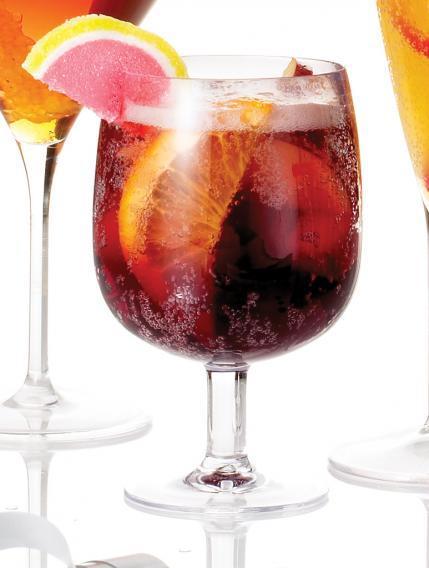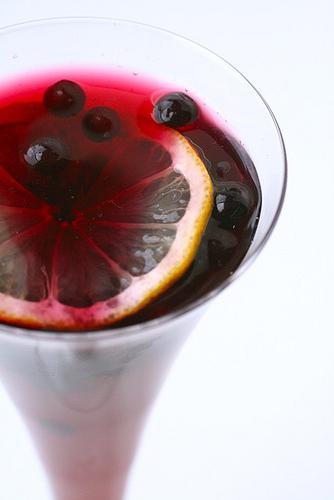The first image is the image on the left, the second image is the image on the right. Considering the images on both sides, is "All of the images contain only one glass that is filled with a beverage." valid? Answer yes or no. Yes. 